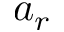Convert formula to latex. <formula><loc_0><loc_0><loc_500><loc_500>a _ { r }</formula> 